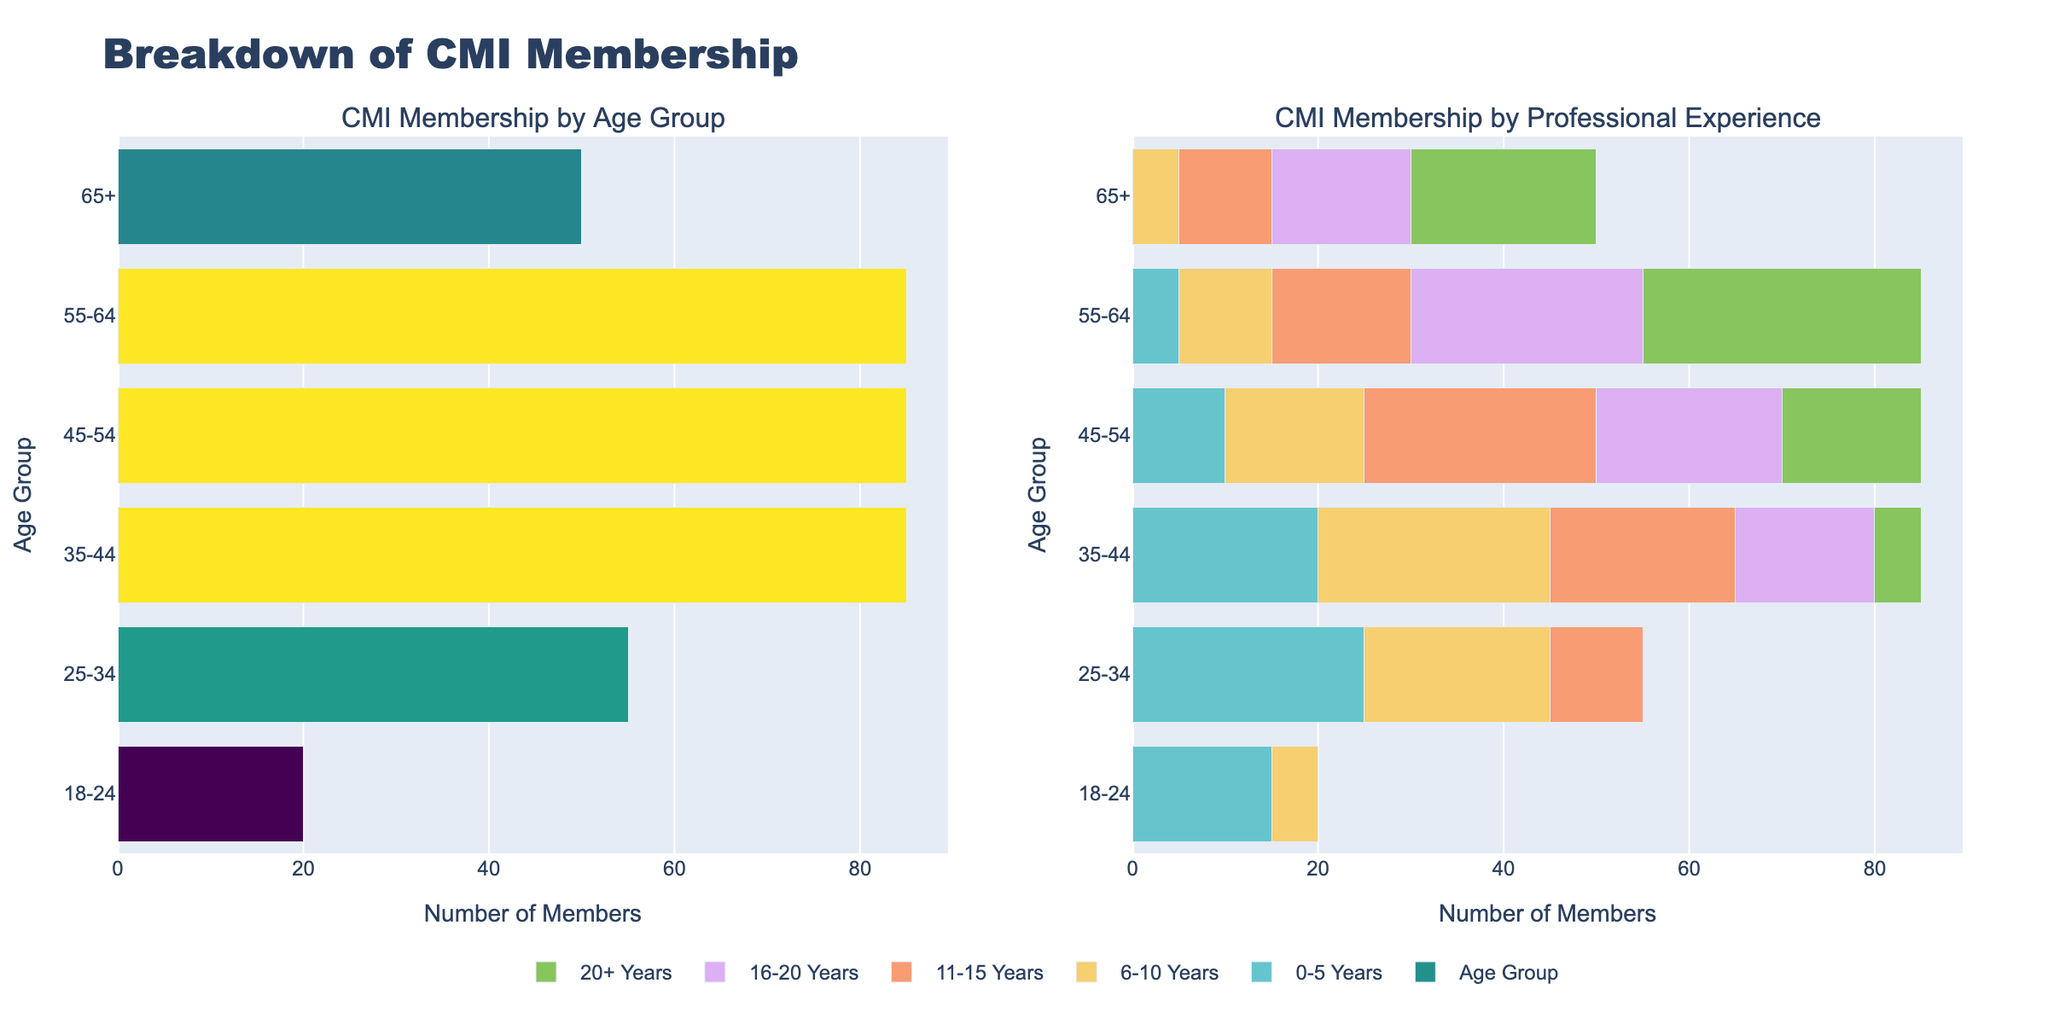What's the title of the figure? The title is located at the top center of the figure and reads "Breakdown of CMI Membership." By looking at the top of the figure, you can see the specified title clearly.
Answer: Breakdown of CMI Membership What does the x-axis represent in the professional experience subplot? The x-axis in the professional experience subplot shows the number of members within each professional experience category. You can determine this by examining the axis labels and interpreting them.
Answer: Number of members Which age group has the highest overall CMI membership? To find the age group with the highest membership, look at the lengths of the bars in the age group subplot. The age group with the longest bar has the highest membership.
Answer: 35-44 In the professional experience subplot, how many members aged 45-54 have 20+ years of experience? Find the bar corresponding to the age group 45-54 in the professional experience subplot, then identify the length of the segment for 20+ years of experience.
Answer: 15 members Between which two adjacent age groups is there the greatest increase in membership for the 0-5 years of professional experience category? Look at the segments for the 0-5 years category across different age groups in the professional experience subplot. Identify the difference between adjacent age groups to find the greatest increase.
Answer: Between 18-24 and 25-34 Which professional experience category has the smallest total number of members? Summing the values across all age groups for each professional experience category and comparing these sums will help find the smallest total. The figure’s bar segment lengths can assist in visual estimation.
Answer: 20+ years For members aged 55-64, which professional experience category has the most members? Observe the segment lengths within the 55-64 age group in the professional experience subplot and identify the longest segment to determine the largest category.
Answer: 20+ years Comparing the age groups 25-34 and 35-44, which has a higher number of members with 6-10 years of professional experience? Compare the bar segments for the 6-10 years category between the age groups 25-34 and 35-44 in the professional experience subplot. Determine which bar is longer.
Answer: 35-44 What is the combined number of members aged 65+ who have 11-20 years of professional experience? Add the number of members from the 11-15 years and 16-20 years categories within the 65+ age group in the professional experience subplot.
Answer: 25 members Which subplot visually indicates the age groups? The first subplot clearly represents the age groups, as it only aggregates data by age without the professional experience dimension.
Answer: Age Group Subplot 